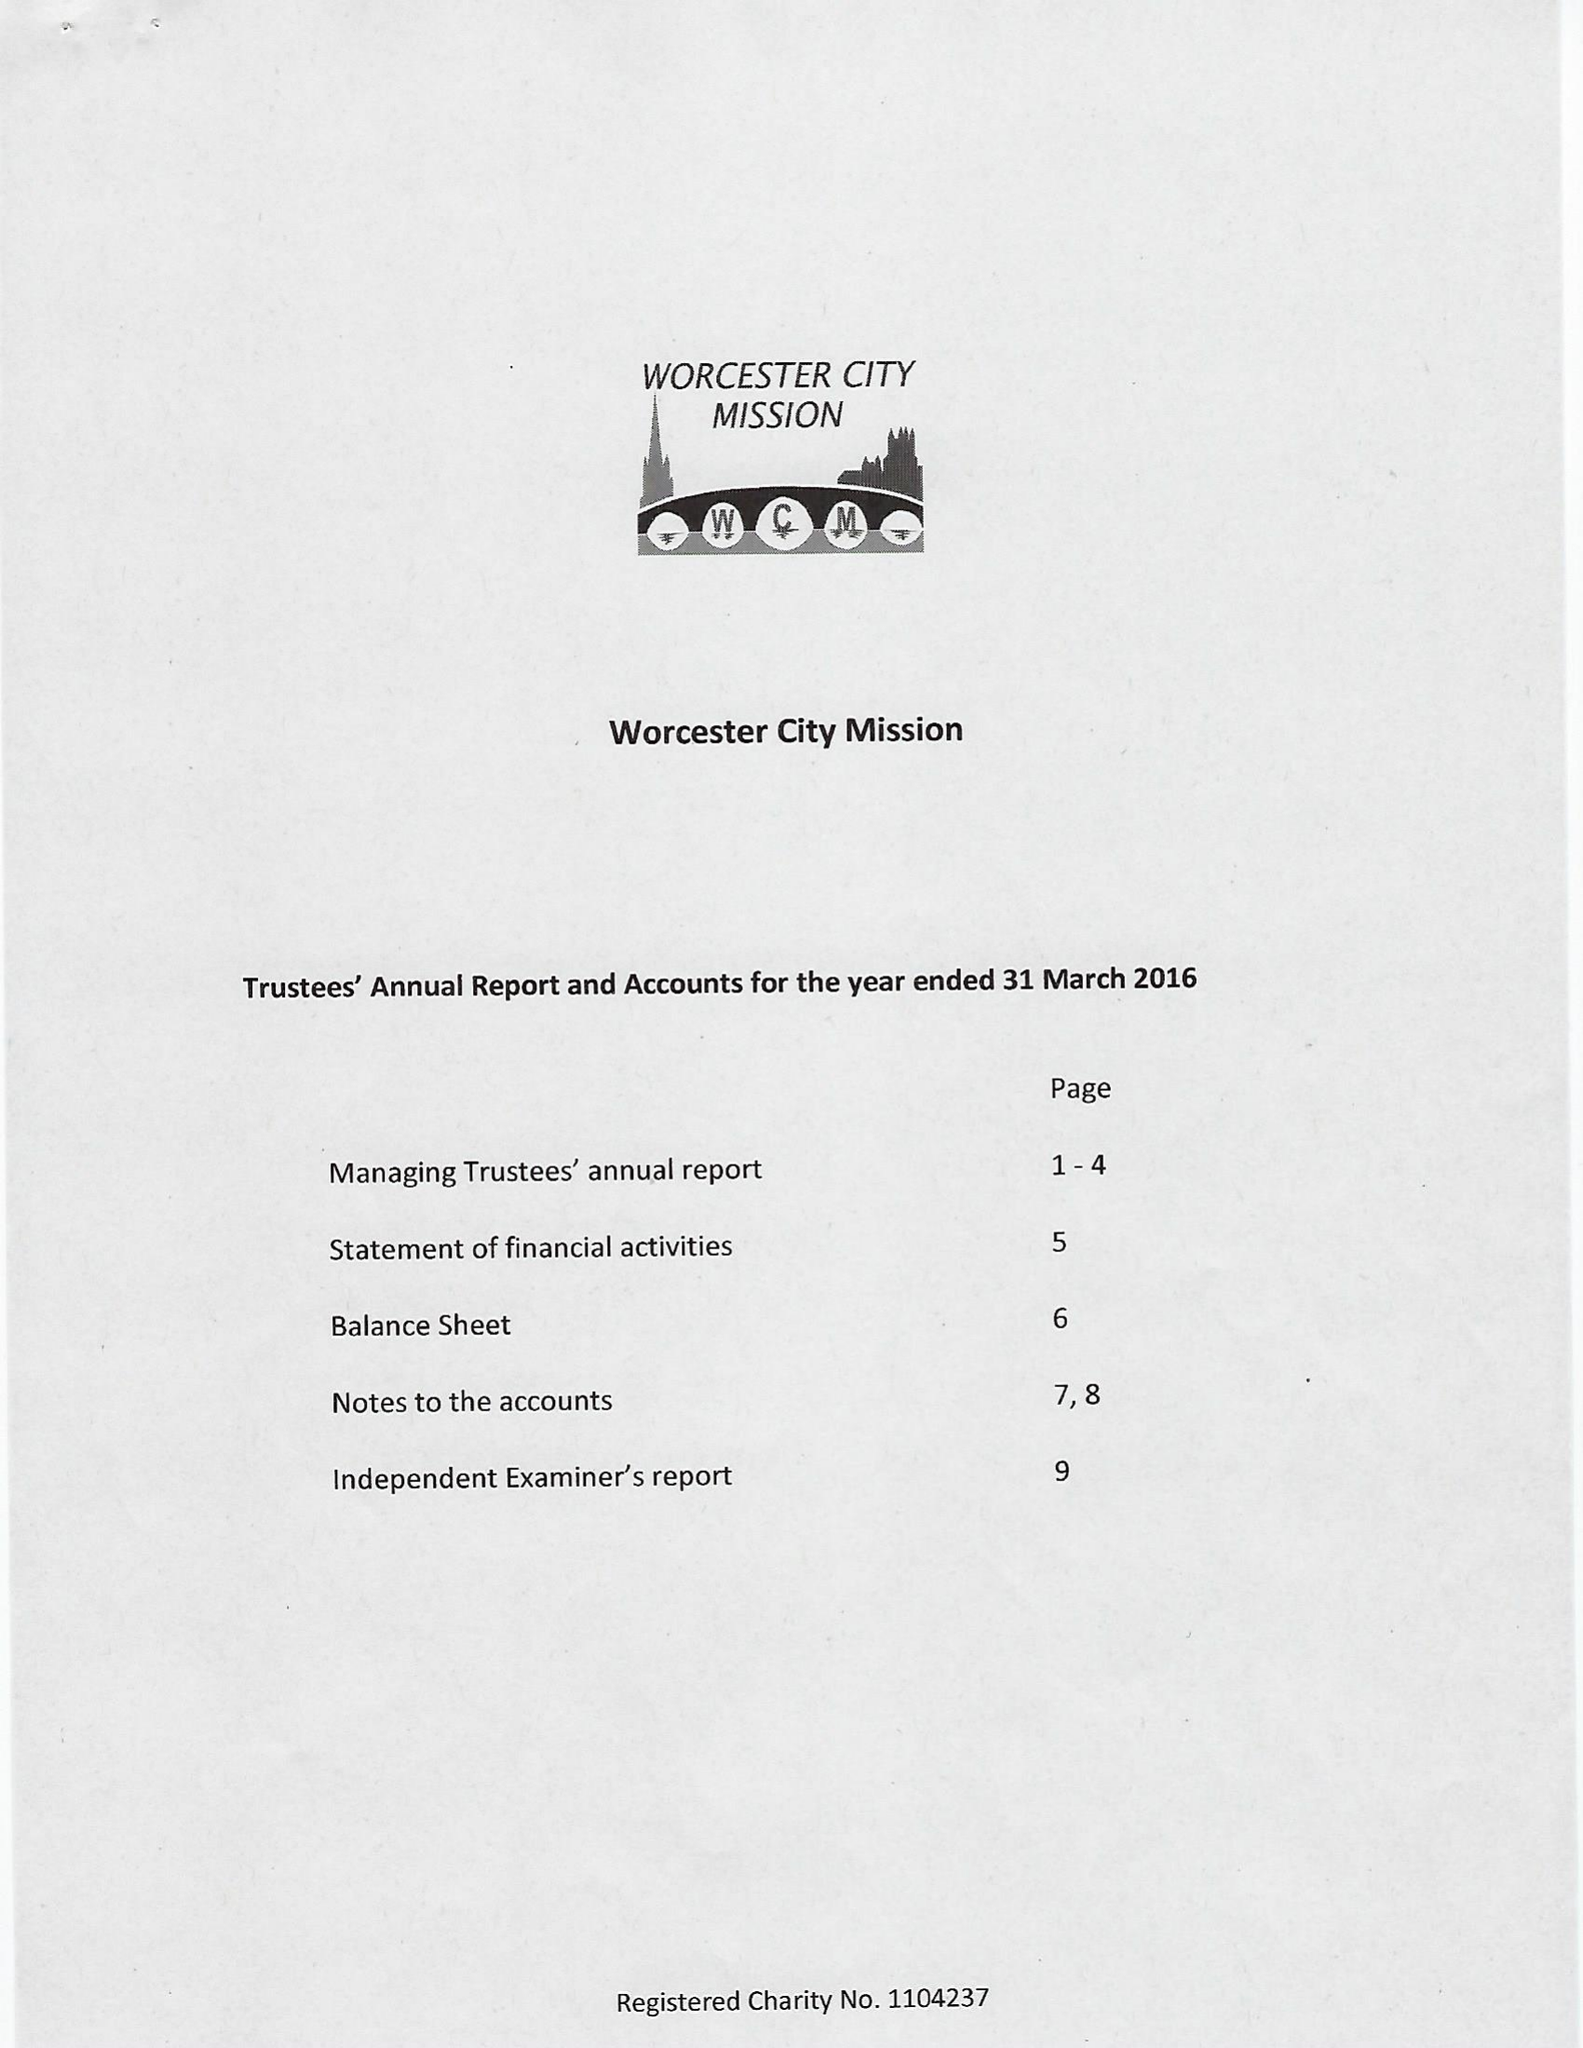What is the value for the charity_number?
Answer the question using a single word or phrase. 1104237 